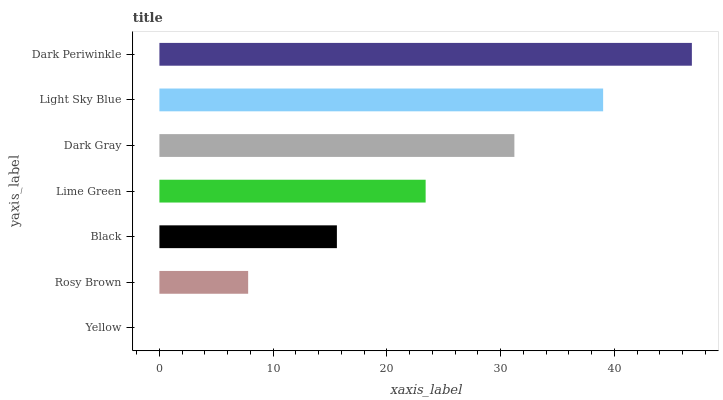Is Yellow the minimum?
Answer yes or no. Yes. Is Dark Periwinkle the maximum?
Answer yes or no. Yes. Is Rosy Brown the minimum?
Answer yes or no. No. Is Rosy Brown the maximum?
Answer yes or no. No. Is Rosy Brown greater than Yellow?
Answer yes or no. Yes. Is Yellow less than Rosy Brown?
Answer yes or no. Yes. Is Yellow greater than Rosy Brown?
Answer yes or no. No. Is Rosy Brown less than Yellow?
Answer yes or no. No. Is Lime Green the high median?
Answer yes or no. Yes. Is Lime Green the low median?
Answer yes or no. Yes. Is Light Sky Blue the high median?
Answer yes or no. No. Is Black the low median?
Answer yes or no. No. 